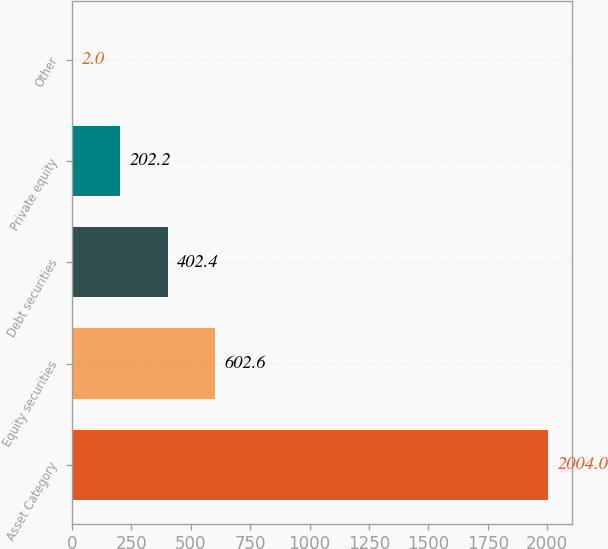Convert chart to OTSL. <chart><loc_0><loc_0><loc_500><loc_500><bar_chart><fcel>Asset Category<fcel>Equity securities<fcel>Debt securities<fcel>Private equity<fcel>Other<nl><fcel>2004<fcel>602.6<fcel>402.4<fcel>202.2<fcel>2<nl></chart> 